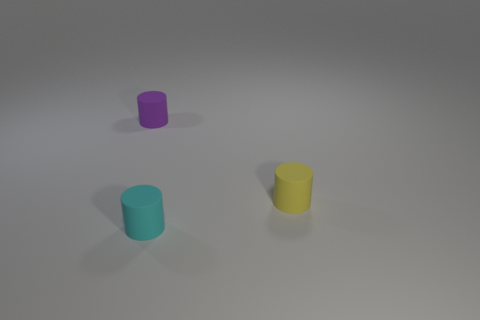Add 2 large gray matte cylinders. How many objects exist? 5 Add 1 small purple things. How many small purple things exist? 2 Subtract 0 green cylinders. How many objects are left? 3 Subtract all big metallic objects. Subtract all small matte cylinders. How many objects are left? 0 Add 3 cylinders. How many cylinders are left? 6 